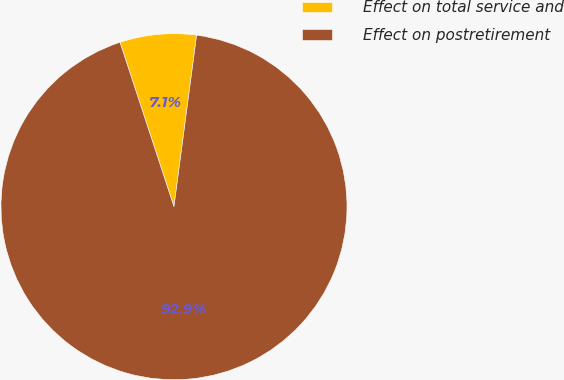Convert chart. <chart><loc_0><loc_0><loc_500><loc_500><pie_chart><fcel>Effect on total service and<fcel>Effect on postretirement<nl><fcel>7.14%<fcel>92.86%<nl></chart> 